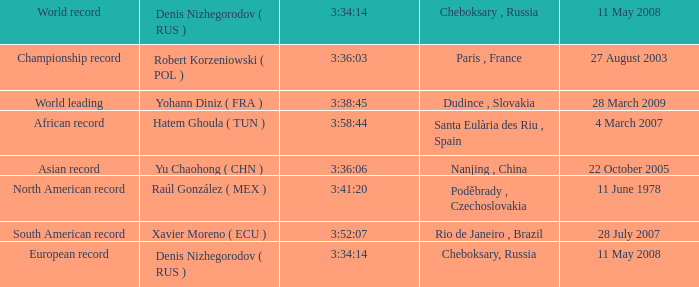When north american record is the world record who is the denis nizhegorodov ( rus )? Raúl González ( MEX ). 